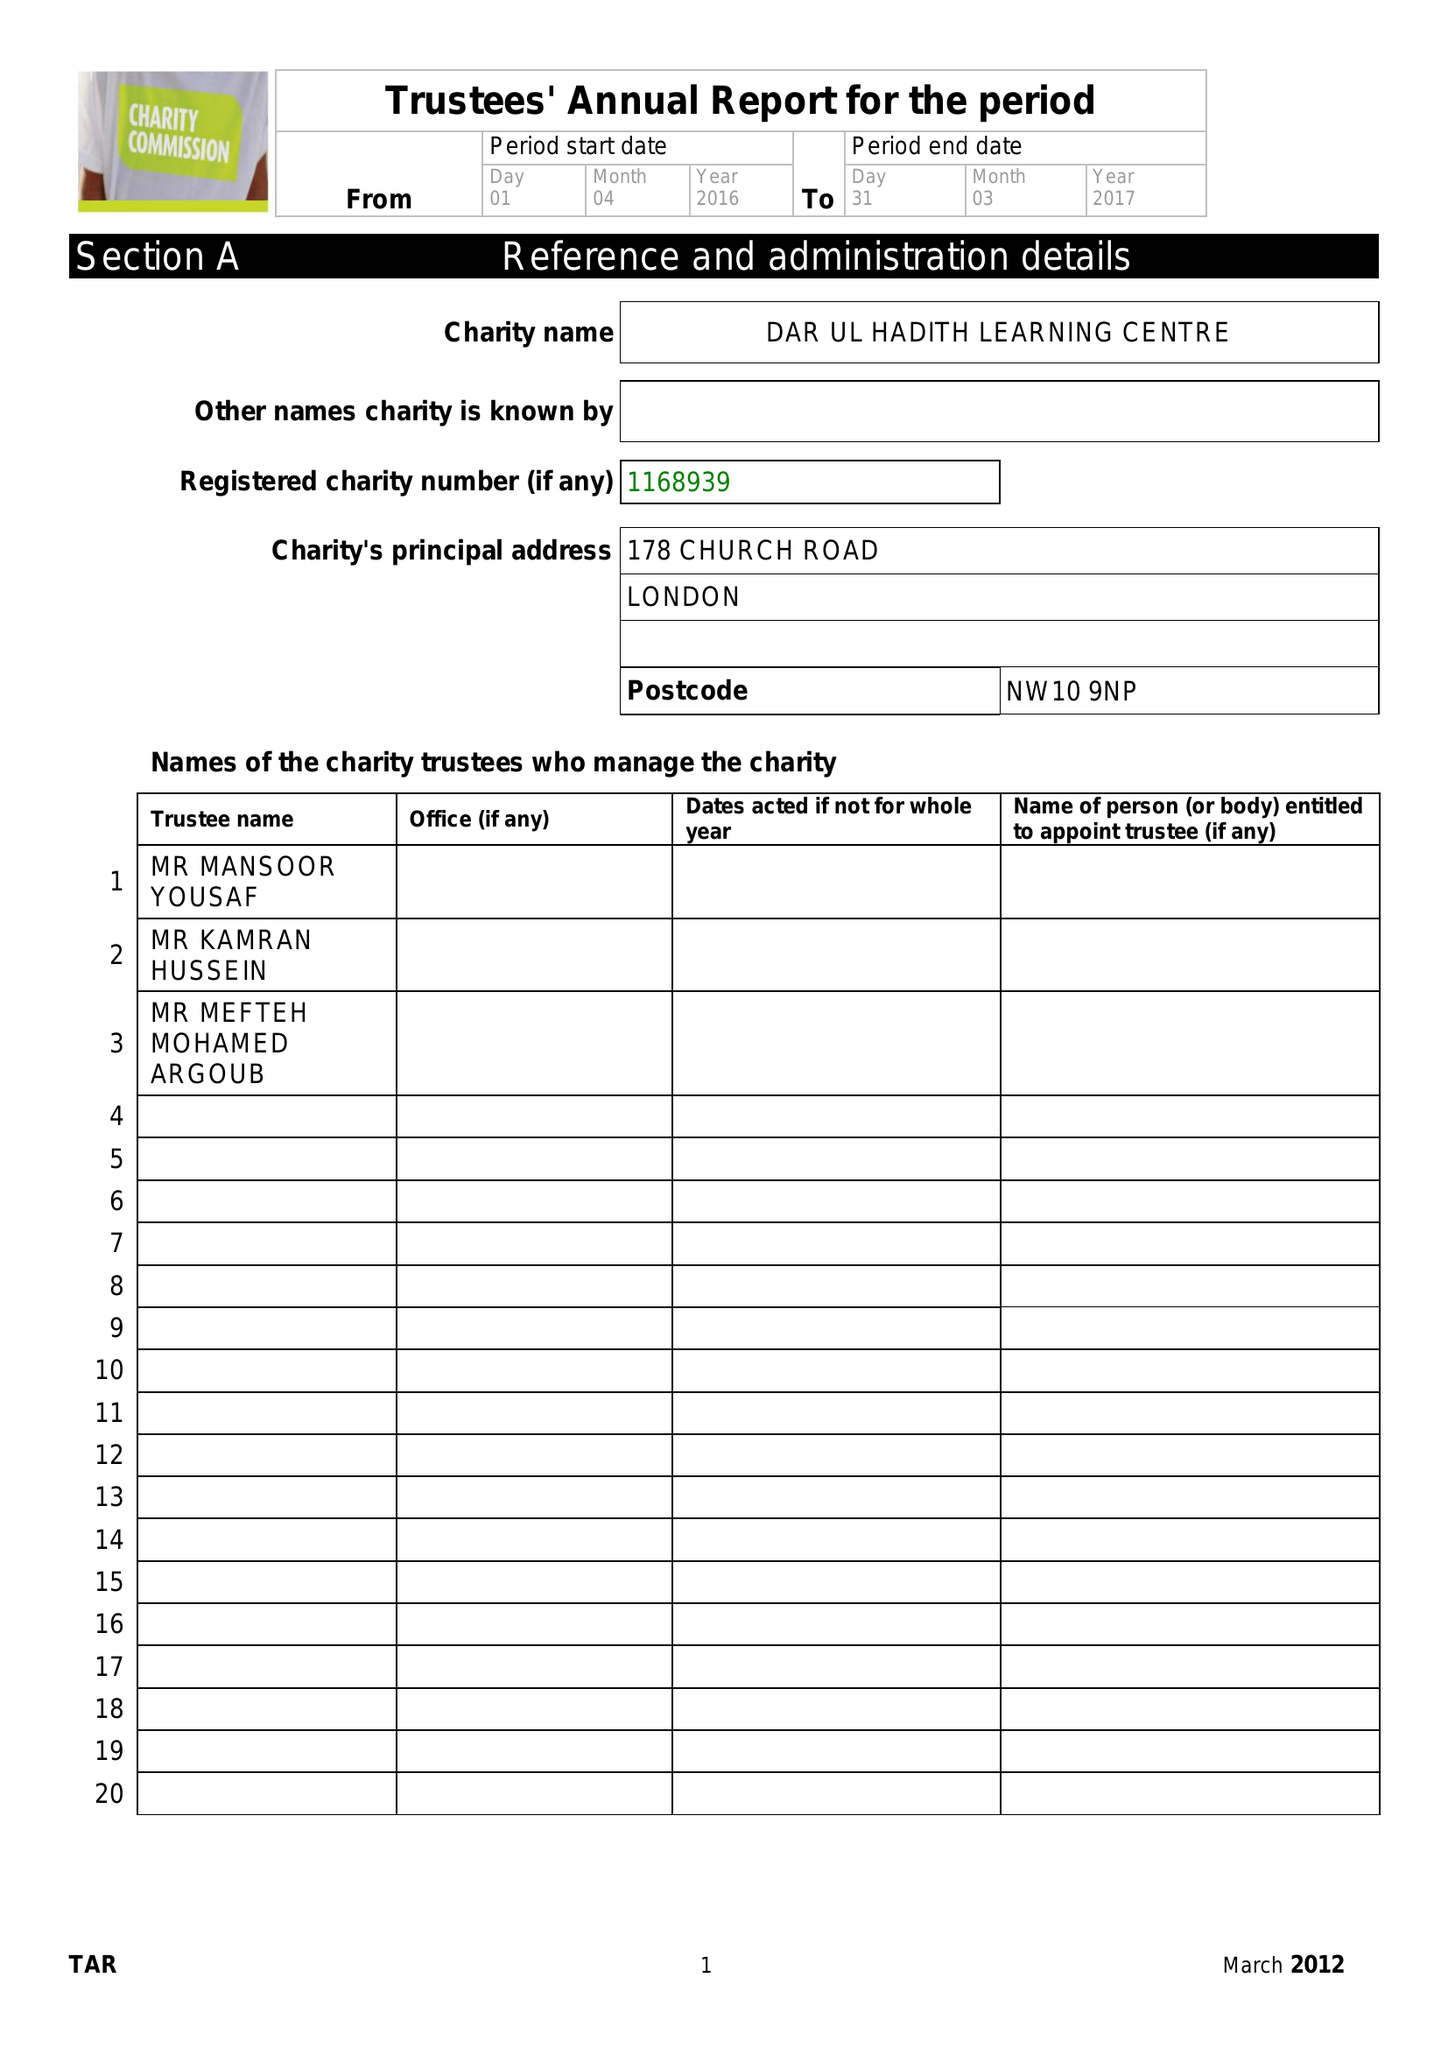What is the value for the charity_number?
Answer the question using a single word or phrase. 1168939 